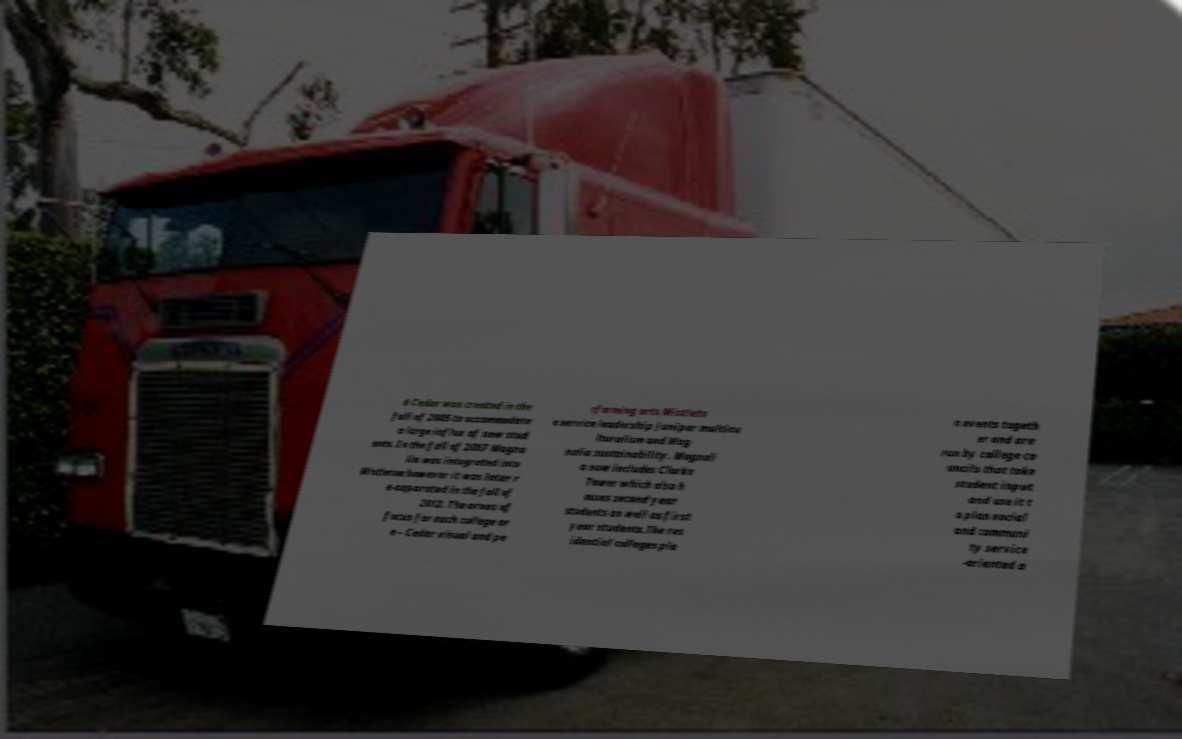For documentation purposes, I need the text within this image transcribed. Could you provide that? d Cedar was created in the fall of 2005 to accommodate a large influx of new stud ents. In the fall of 2007 Magno lia was integrated into Mistletoe however it was later r e-separated in the fall of 2012. The areas of focus for each college ar e – Cedar visual and pe rforming arts Mistleto e service leadership Juniper multicu lturalism and Mag nolia sustainability. Magnoli a now includes Clarke Tower which also h ouses second year students as well as first year students.The res idential colleges pla n events togeth er and are run by college co uncils that take student input and use it t o plan social and communi ty service -oriented a 